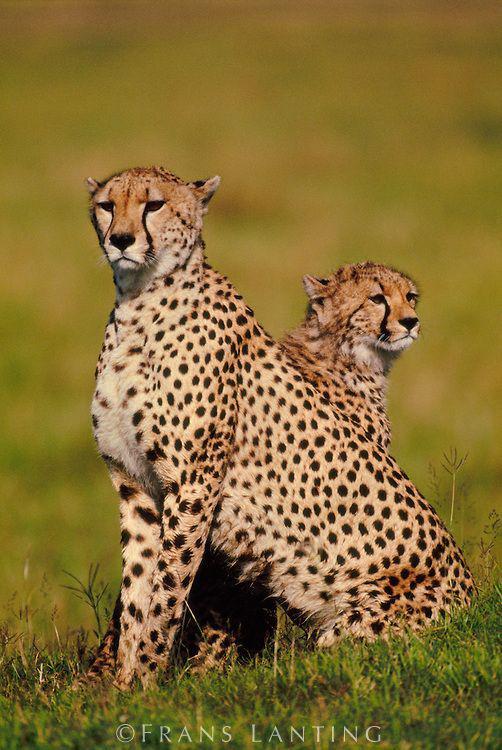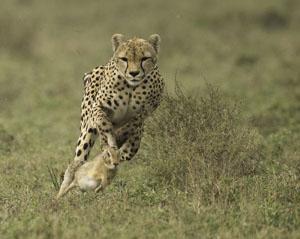The first image is the image on the left, the second image is the image on the right. Examine the images to the left and right. Is the description "One image features one cheetah bounding forward." accurate? Answer yes or no. Yes. 